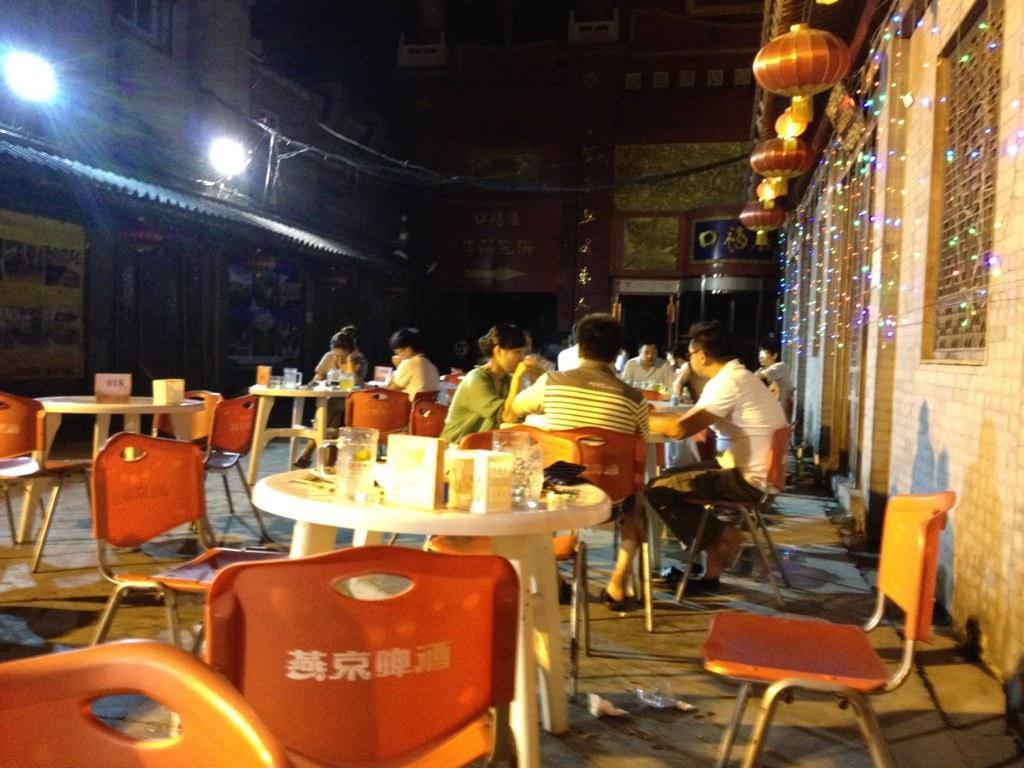Can you describe this image briefly? In this picture there are group of people. There are glasses on the table. At the right side there are light hangings and at the back there is a building. At the left there are lights. 